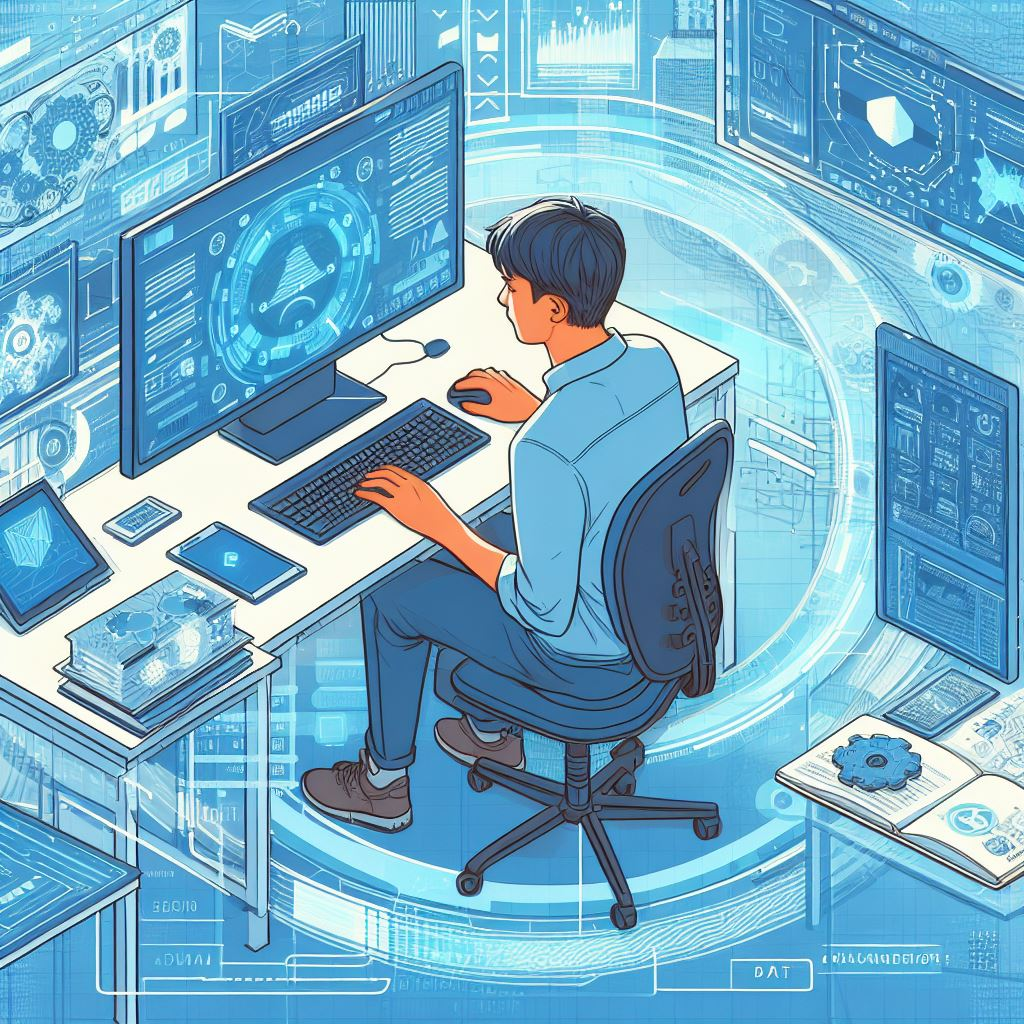Décris l'image
 L'image montre un jeune homme assis à son bureau en train de travailler sur un ordinateur. Il semble être dans un espace de travail futuriste et immersif, entouré de technologies avancées.

**Voici les éléments clés de l'illustration:**

* **Le personnage:** Un jeune homme, probablement un programmeur ou un analyste de données, vu de dos, absorbé par son travail. 
* **L'environnement de travail:** Le bureau est moderne et minimaliste. Il est entouré d'écrans holographiques affichant des données, des graphiques, des schémas et des interfaces futuristes. L'ensemble est baigné d'une lumière bleue et turquoise, créant une ambiance technologique.
* **Les objets:** On distingue sur le bureau un ordinateur avec un clavier complet, une souris, une tablette graphique, des documents empilés et un carnet ouvert avec des engrenages dessinés dessus, suggérant un travail de conception ou d'ingénierie.
* **La perspective:** L'illustration est réalisée en vue isométrique, ce qui donne une impression de profondeur et permet de visualiser l'ensemble de l'espace de travail.

**Interprétation globale:**

L'image suggère un environnement de travail high-tech, axé sur les données et la technologie. Le personnage semble être au cœur d'un système informatique complexe, contrôlant et analysant l'information. L'ambiance futuriste et immersive souligne l'importance croissante de la technologie dans le monde professionnel. 